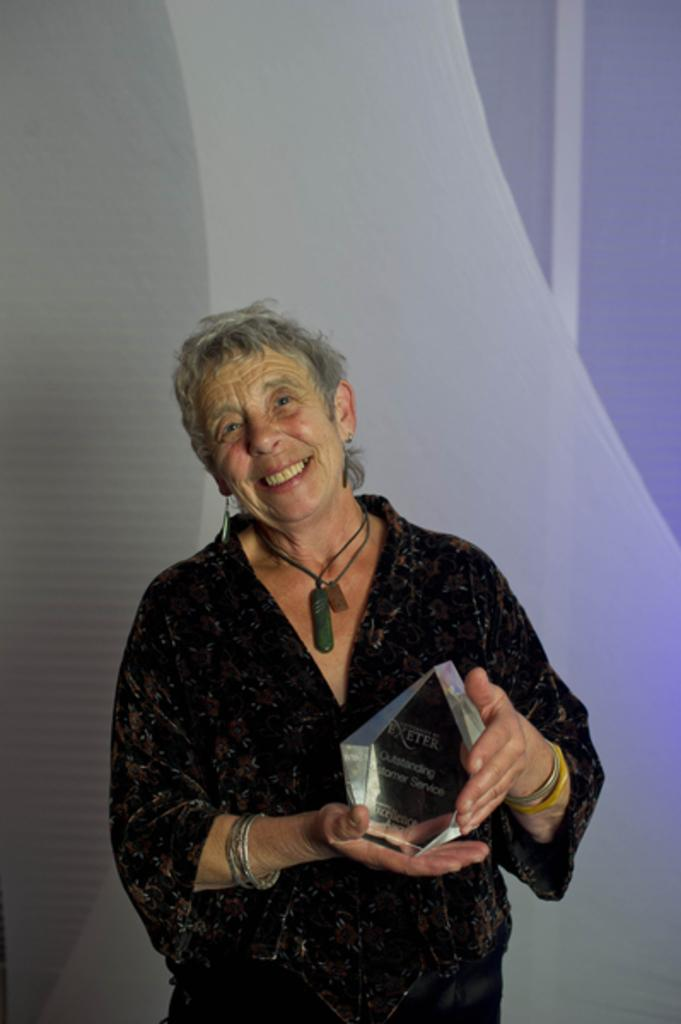What is the main subject of the image? There is a woman standing in the image. What is the woman holding in the image? The woman is holding an object. Can you describe the object the woman is holding? The object has text on it. What can be seen in the background of the image? There is a board visible in the background of the image. Can you tell me how many toads are sitting on the board in the background? There are no toads present in the image, and therefore no such activity can be observed. What level of water is visible in the image? There is no water visible in the image. 